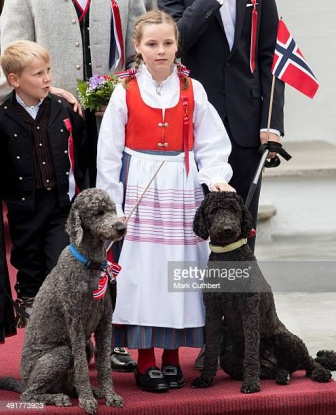Imagine the black poodle is a world-famous detective. What kind of case might it be solving at this event? The black poodle, known as Detective Shadow, was not just any pet at this event. Hired secretly by the royal family, Shadow was on a delicate mission – to uncover the mystery of the missing historic brooch, an heirloom said to bring prosperity to Norway. With keen senses and dressed in a tiny bow tie, Shadow mingled through the crowd, subtly sniffing out clues and observing every movement. As the festivities continued, Shadow's sharp eyes caught a glint of something suspicious around the neck of a notorious art thief. Using a clever distraction, Shadow managed to retrieve the brooch, returning it to the grateful hands of the King, thus securing Norway’s heritage once more. 